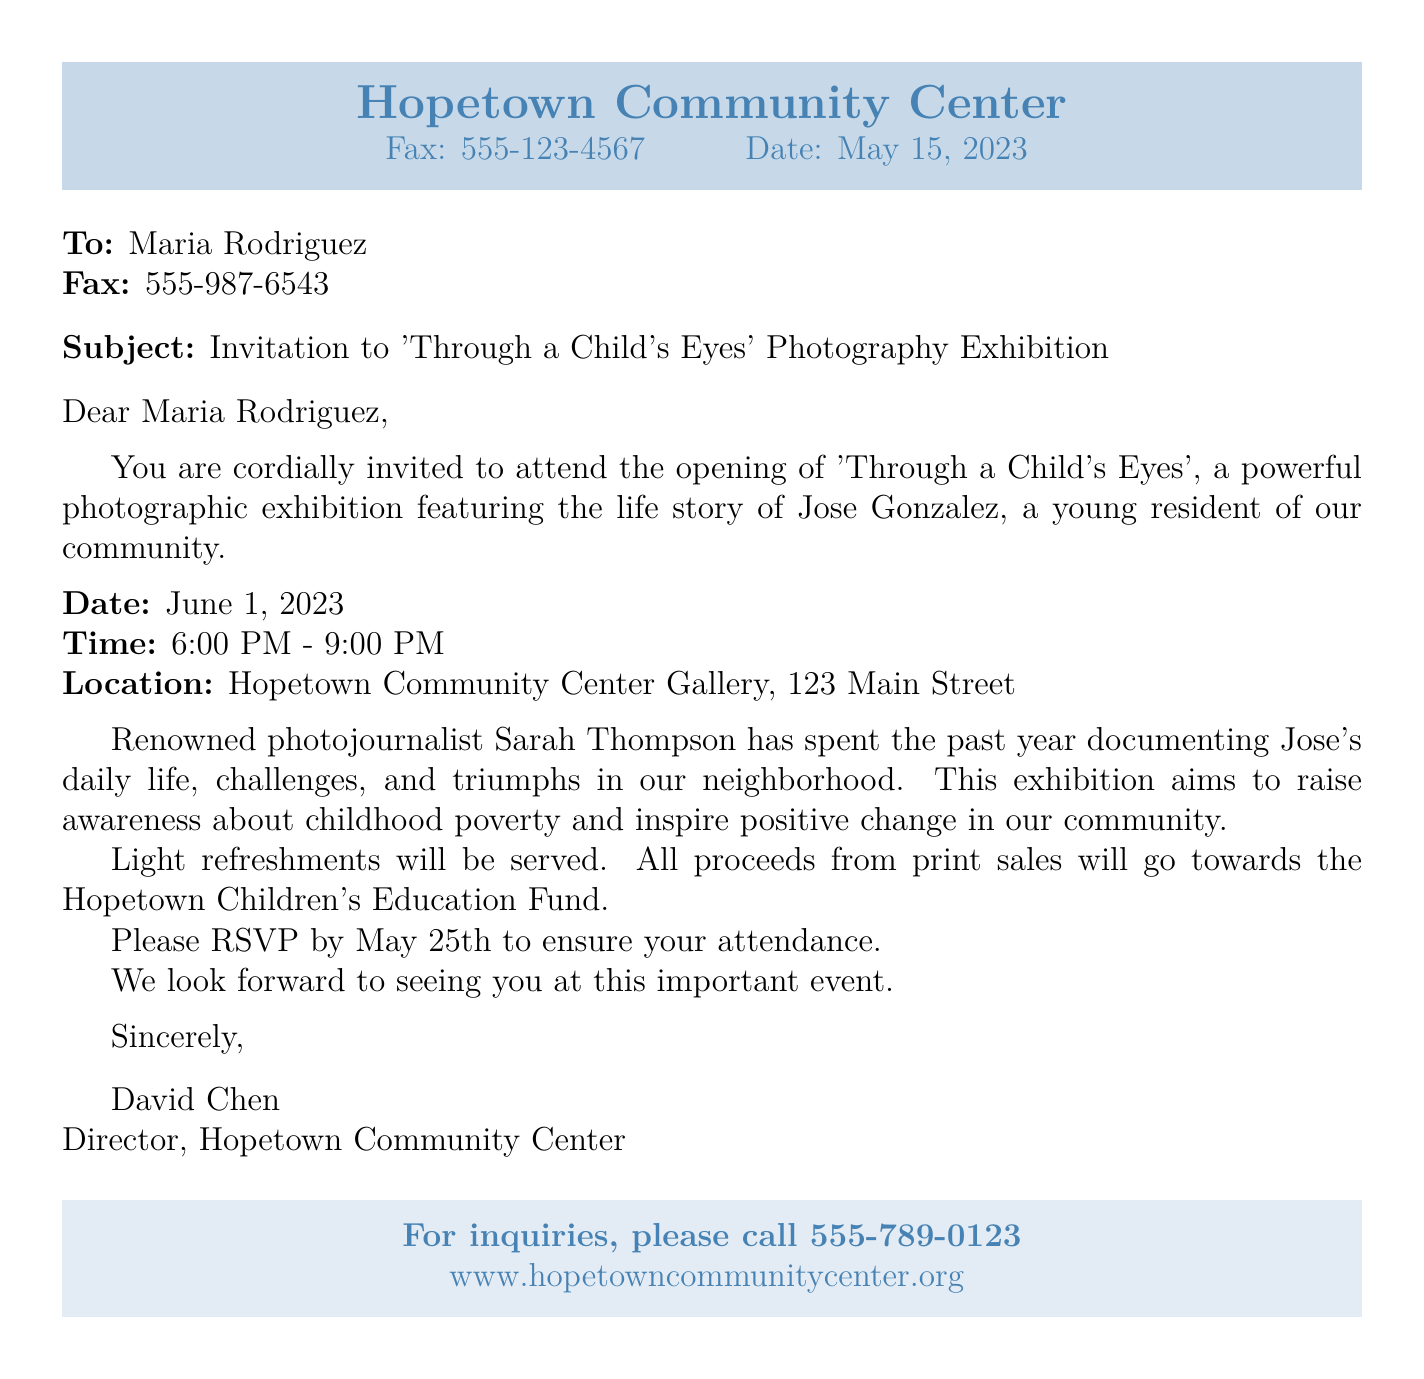What is the title of the exhibition? The title of the exhibition is mentioned in the subject line of the fax.
Answer: Through a Child's Eyes Who is the young resident featured in the exhibition? The fax states the name of the child whose life story is being showcased.
Answer: Jose Gonzalez What is the date of the exhibition? The date is explicitly mentioned in the details provided in the document.
Answer: June 1, 2023 What time does the exhibition start? The starting time for the exhibition is given in the document.
Answer: 6:00 PM What will be served at the exhibition? The document mentions refreshments for the attendees.
Answer: Light refreshments What is the purpose of the exhibition? The reason for holding the exhibition is outlined in the invitation.
Answer: Raise awareness about childhood poverty Who is the photojournalist featured in the exhibition? The fax introduces the photojournalist who documented the child's life.
Answer: Sarah Thompson When is the RSVP deadline? The specific date for RSVPs is indicated in the invitation details.
Answer: May 25th What is the location of the exhibition? The venue for the exhibition is stated in the document.
Answer: Hopetown Community Center Gallery, 123 Main Street 